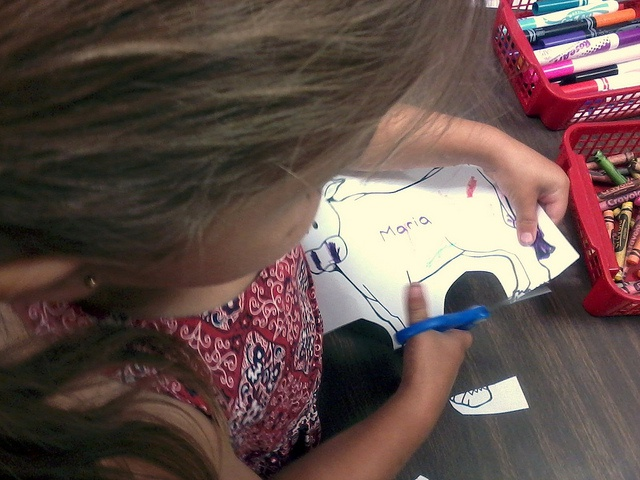Describe the objects in this image and their specific colors. I can see people in black, maroon, and gray tones and scissors in black, blue, gray, navy, and darkblue tones in this image. 